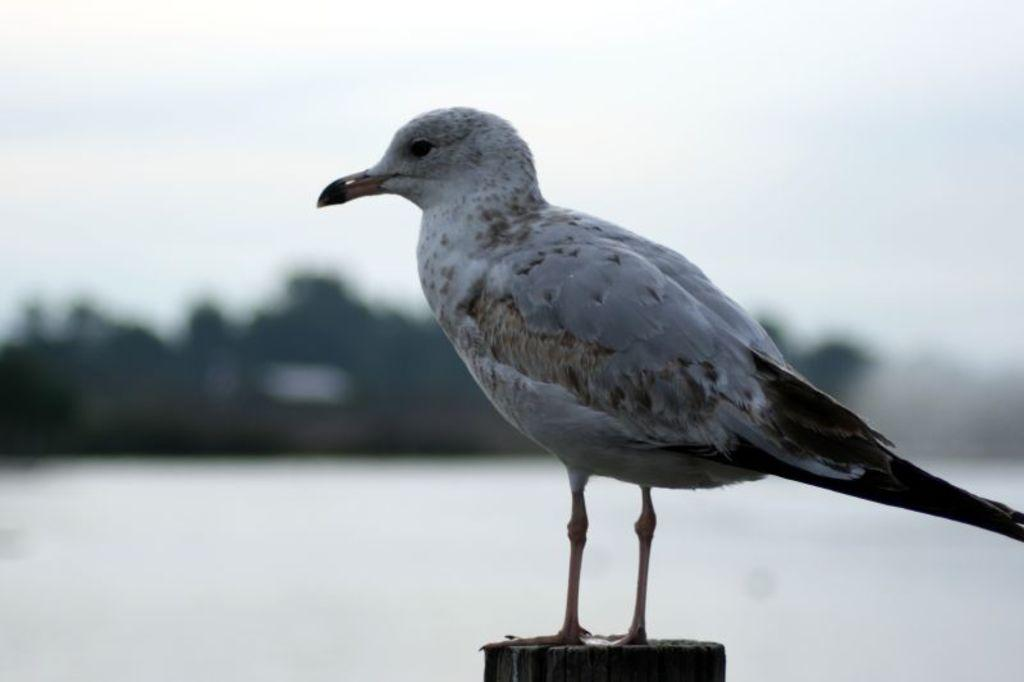What type of animal is in the image? There is a bird in the image. What is the bird standing on? The bird is standing on a wooden object. Can you describe the background of the image? The background of the image is blurry. What type of elbow can be seen in the image? There is no elbow present in the image. What key is used to unlock the bird's cage in the image? There is no cage or key present in the image. 